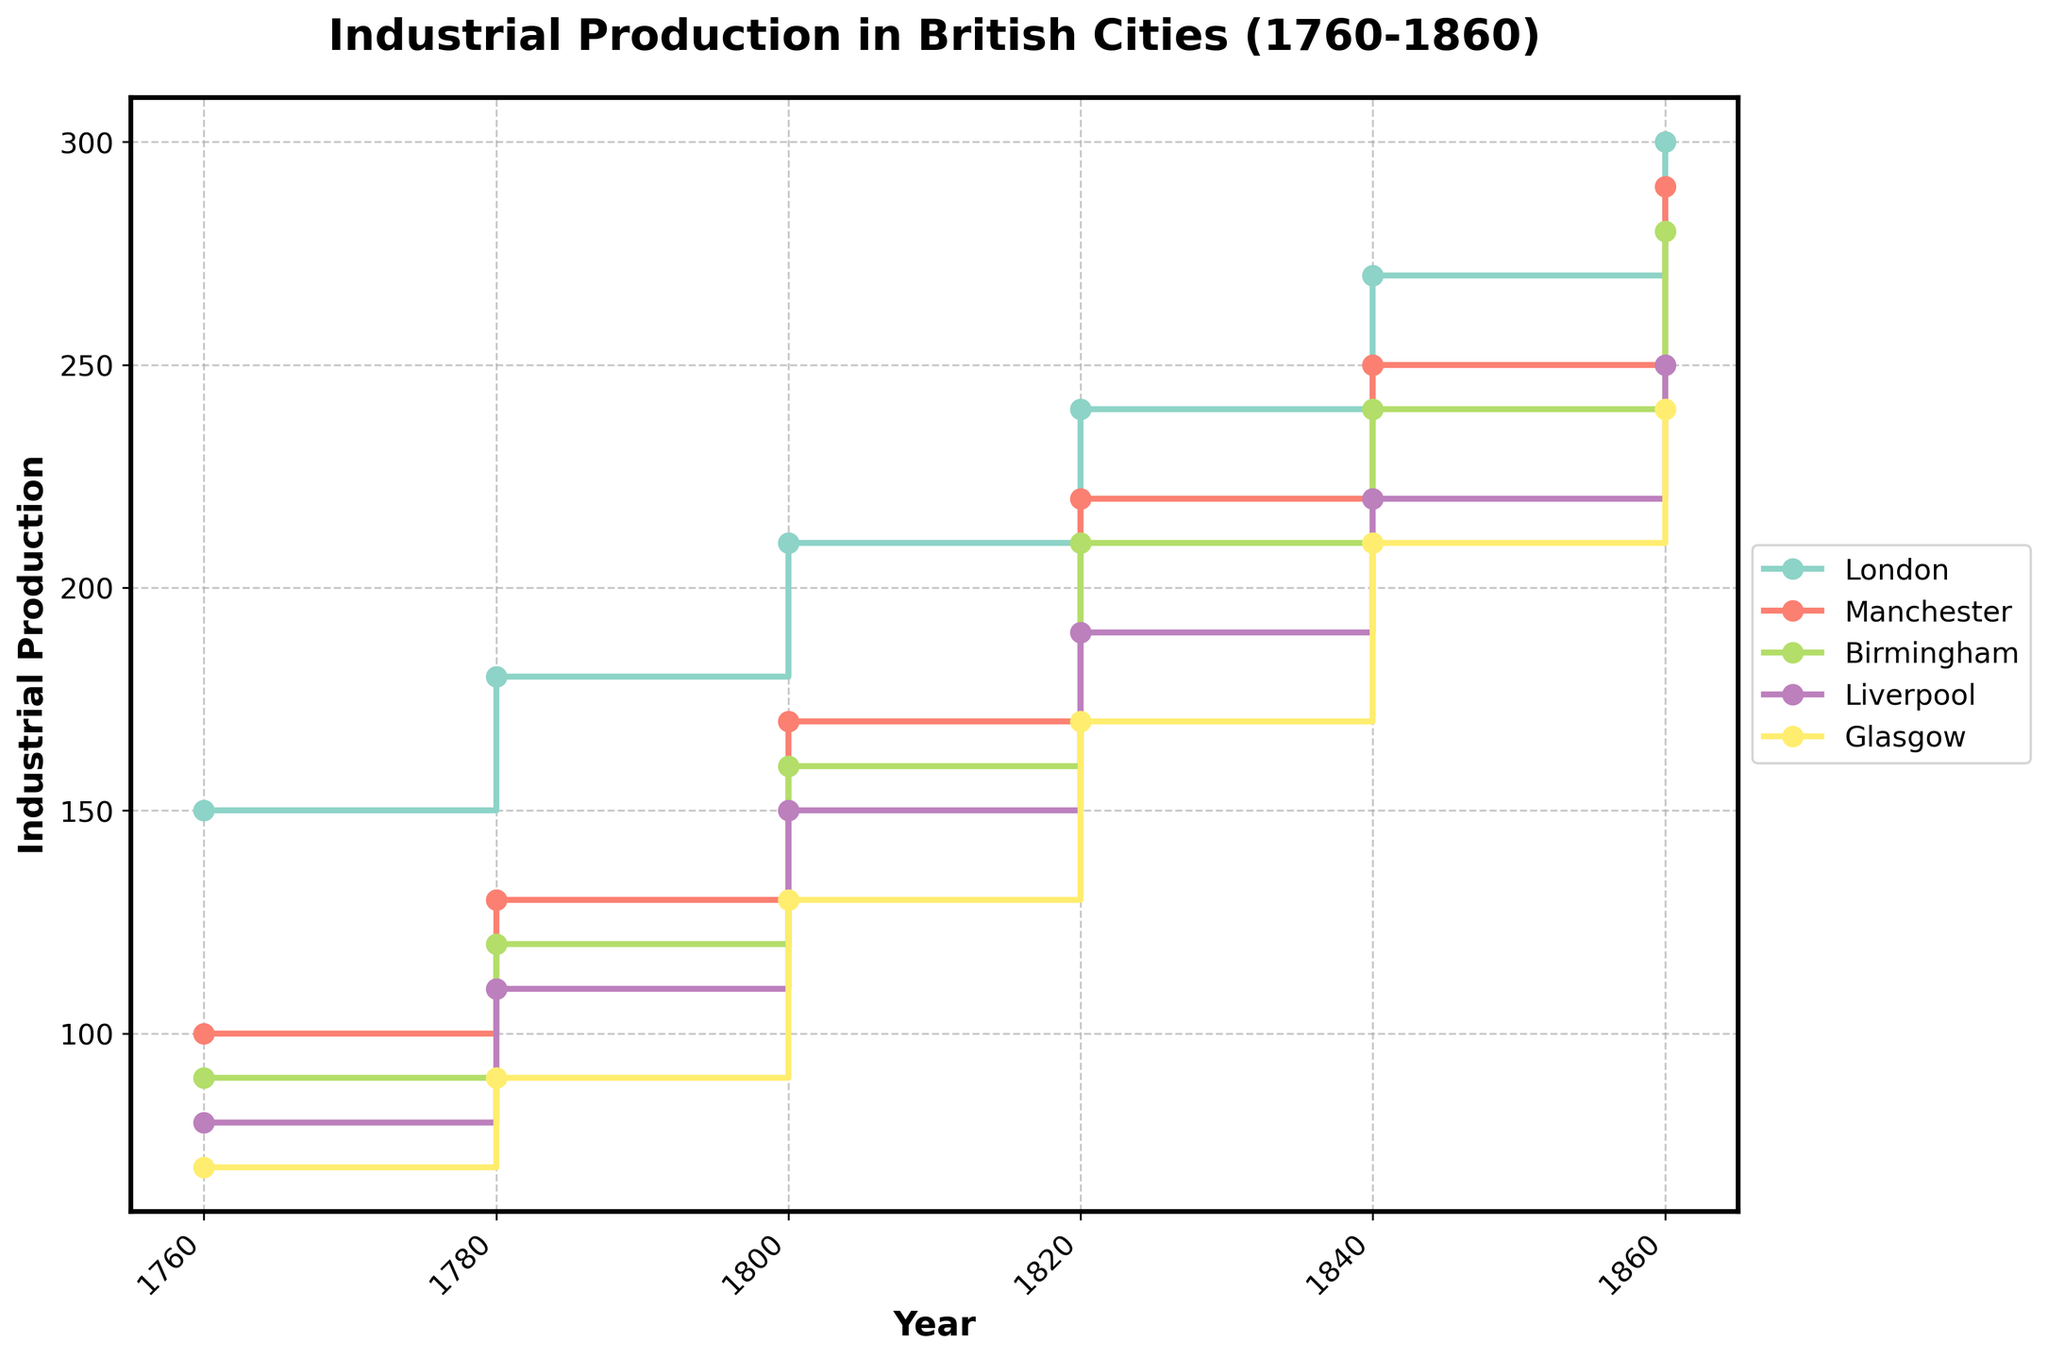Which city shows the highest industrial production in 1860? Look at the endpoint of the lines in the plot at the year 1860. The line representing London ends at the highest point.
Answer: London Which city experienced the greatest increase in industrial production from 1760 to 1860? Calculate the difference between the values in 1860 and 1760 for each city. London increased from 150 to 300, which is the largest difference of 150.
Answer: London How does the industrial production of Manchester in 1840 compare to that of Liverpool in the same year? Find the respective points for Manchester and Liverpool in 1840 and compare them. Manchester's value is 250, and Liverpool's value is 220.
Answer: Manchester is higher What is the time period where Glasgow's industrial production saw the most significant increase? Observe Glasgow's line and note the steepest segment. The steepest increase for Glasgow appears from 1800 to 1820.
Answer: 1800 to 1820 Which cities had an industrial production below 100 in 1760? Check the starting points of each line at the year 1760. Liverpool (80) and Glasgow (70) are below 100.
Answer: Liverpool and Glasgow Between 1820 and 1840, which city had the least increase in industrial production? Calculate the differences between the values from 1820 to 1840 for each city. London increased by 30, Manchester by 30, Birmingham by 30, Liverpool by 30, and Glasgow by 40. Therefore, all cities except Glasgow had the same minimum increase.
Answer: London, Manchester, Birmingham, Liverpool (each had an increase of 30) How many cities had an industrial production of exactly 210 in any year? Check the plot for points that intersect the 210 mark. London (1820), Manchester (1840), and Glasgow (1840).
Answer: 3 cities What is Birmingham's industrial production in 1800? Look for the point on Birmingham's line at 1800; it is 160.
Answer: 160 What is the average industrial production of Liverpool in the years provided? Sum Liverpool's values and divide by the number of years: (80 + 110 + 150 + 190 + 220 + 250)/6 = 1000/6 ≈ 166.67
Answer: approximately 166.67 How did Manchester's industrial production in 1860 compare with that of Birmingham in the same year? Compare the endpoints of Manchester and Birmingham's lines in 1860; both are at 290 and 280, respectively.
Answer: Manchester is higher 